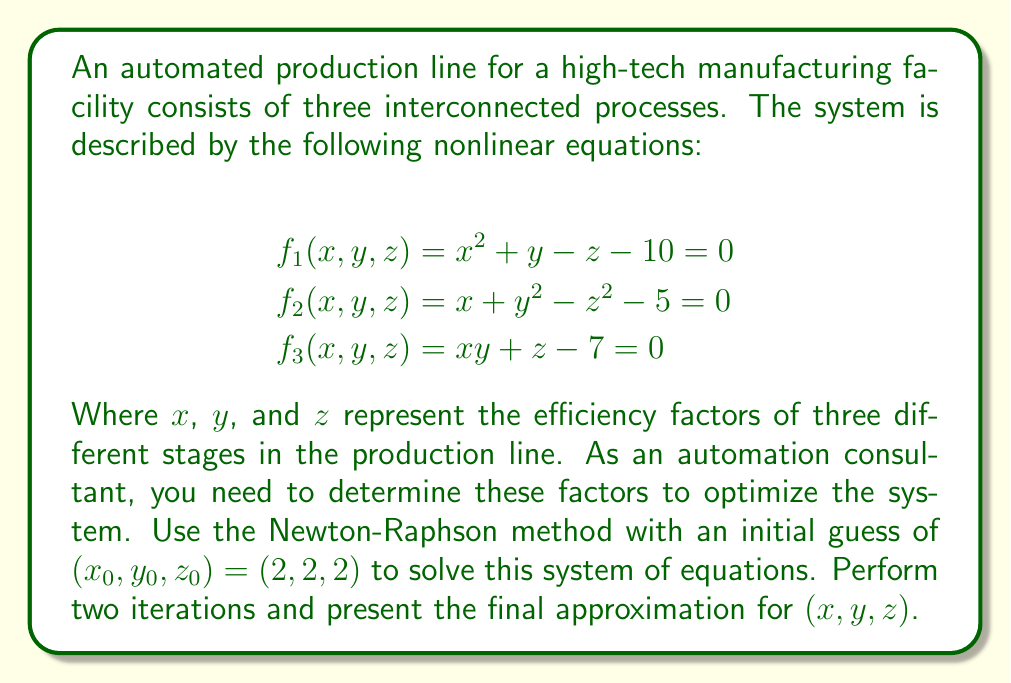Help me with this question. To solve this system using the Newton-Raphson method, we follow these steps:

1) First, we define the Jacobian matrix:

$$J = \begin{bmatrix}
\frac{\partial f_1}{\partial x} & \frac{\partial f_1}{\partial y} & \frac{\partial f_1}{\partial z} \\
\frac{\partial f_2}{\partial x} & \frac{\partial f_2}{\partial y} & \frac{\partial f_2}{\partial z} \\
\frac{\partial f_3}{\partial x} & \frac{\partial f_3}{\partial y} & \frac{\partial f_3}{\partial z}
\end{bmatrix} = \begin{bmatrix}
2x & 1 & -1 \\
1 & 2y & -2z \\
y & x & 1
\end{bmatrix}$$

2) The Newton-Raphson iteration formula is:

$$\begin{bmatrix} x_{n+1} \\ y_{n+1} \\ z_{n+1} \end{bmatrix} = \begin{bmatrix} x_n \\ y_n \\ z_n \end{bmatrix} - J^{-1} \begin{bmatrix} f_1(x_n, y_n, z_n) \\ f_2(x_n, y_n, z_n) \\ f_3(x_n, y_n, z_n) \end{bmatrix}$$

3) First iteration $(n = 0)$:

Evaluate $f_1, f_2, f_3$ at $(2, 2, 2)$:
$$f_1(2, 2, 2) = 2^2 + 2 - 2 - 10 = -6$$
$$f_2(2, 2, 2) = 2 + 2^2 - 2^2 - 5 = -3$$
$$f_3(2, 2, 2) = 2 \cdot 2 + 2 - 7 = -1$$

Evaluate Jacobian at $(2, 2, 2)$:
$$J = \begin{bmatrix}
4 & 1 & -1 \\
1 & 4 & -4 \\
2 & 2 & 1
\end{bmatrix}$$

Solve the system:
$$\begin{bmatrix} \Delta x \\ \Delta y \\ \Delta z \end{bmatrix} = J^{-1} \begin{bmatrix} -6 \\ -3 \\ -1 \end{bmatrix}$$

This gives: $\Delta x \approx 1.2857, \Delta y \approx 0.4286, \Delta z \approx -0.1429$

New approximation:
$$(x_1, y_1, z_1) = (3.2857, 2.4286, 1.8571)$$

4) Second iteration $(n = 1)$:

Repeat the process with the new values. After calculations:

$$(x_2, y_2, z_2) \approx (3.0936, 2.2968, 1.9694)$$

This is our final approximation after two iterations.
Answer: $(x, y, z) \approx (3.0936, 2.2968, 1.9694)$ 